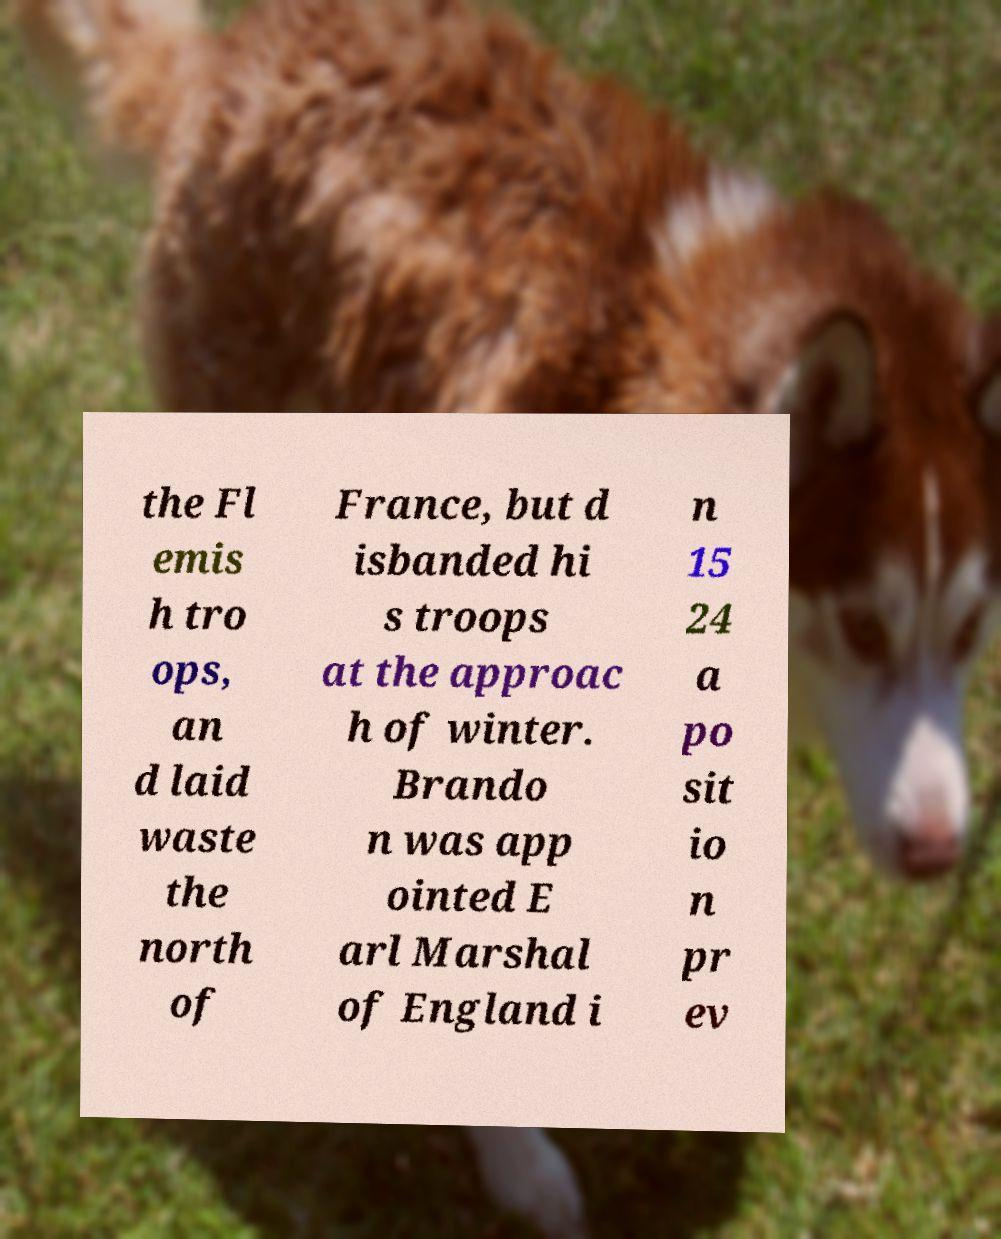Please read and relay the text visible in this image. What does it say? the Fl emis h tro ops, an d laid waste the north of France, but d isbanded hi s troops at the approac h of winter. Brando n was app ointed E arl Marshal of England i n 15 24 a po sit io n pr ev 